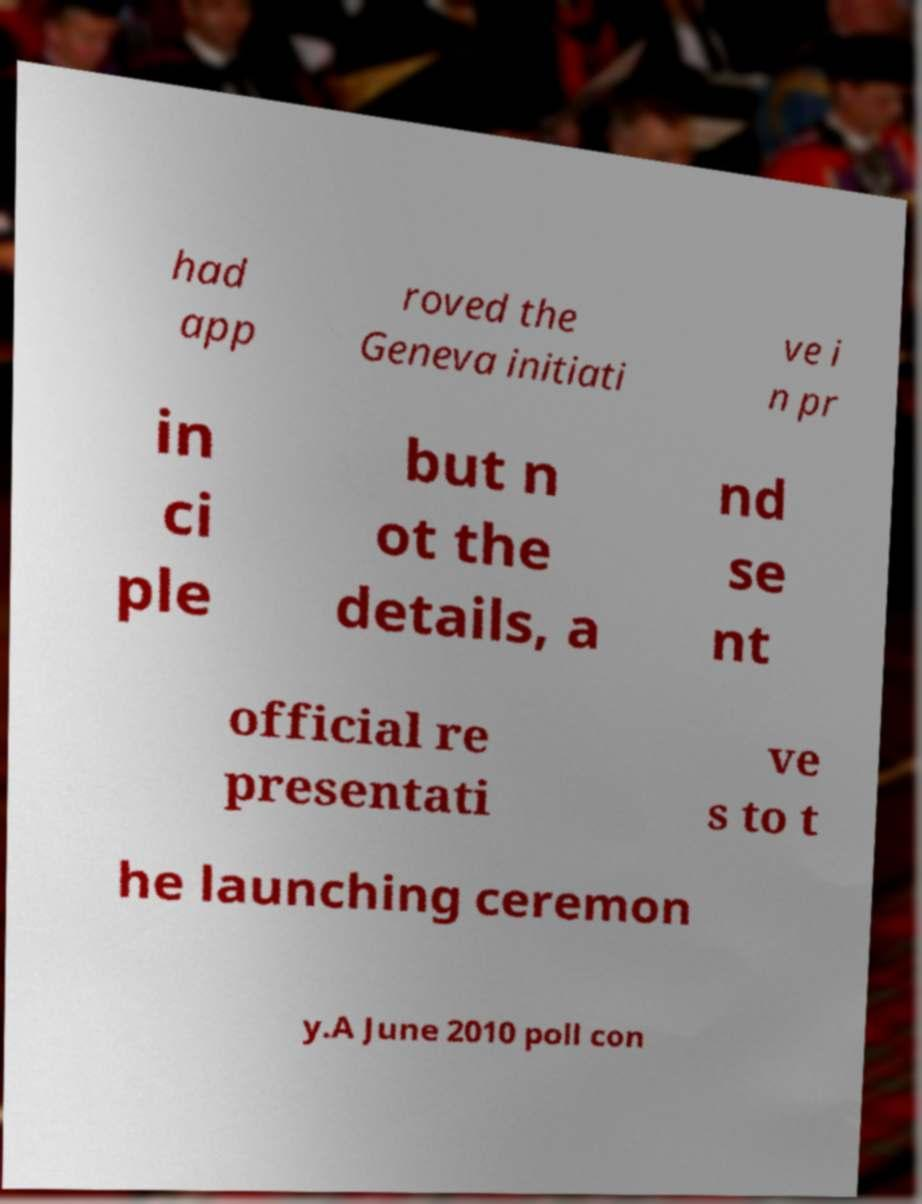What messages or text are displayed in this image? I need them in a readable, typed format. had app roved the Geneva initiati ve i n pr in ci ple but n ot the details, a nd se nt official re presentati ve s to t he launching ceremon y.A June 2010 poll con 